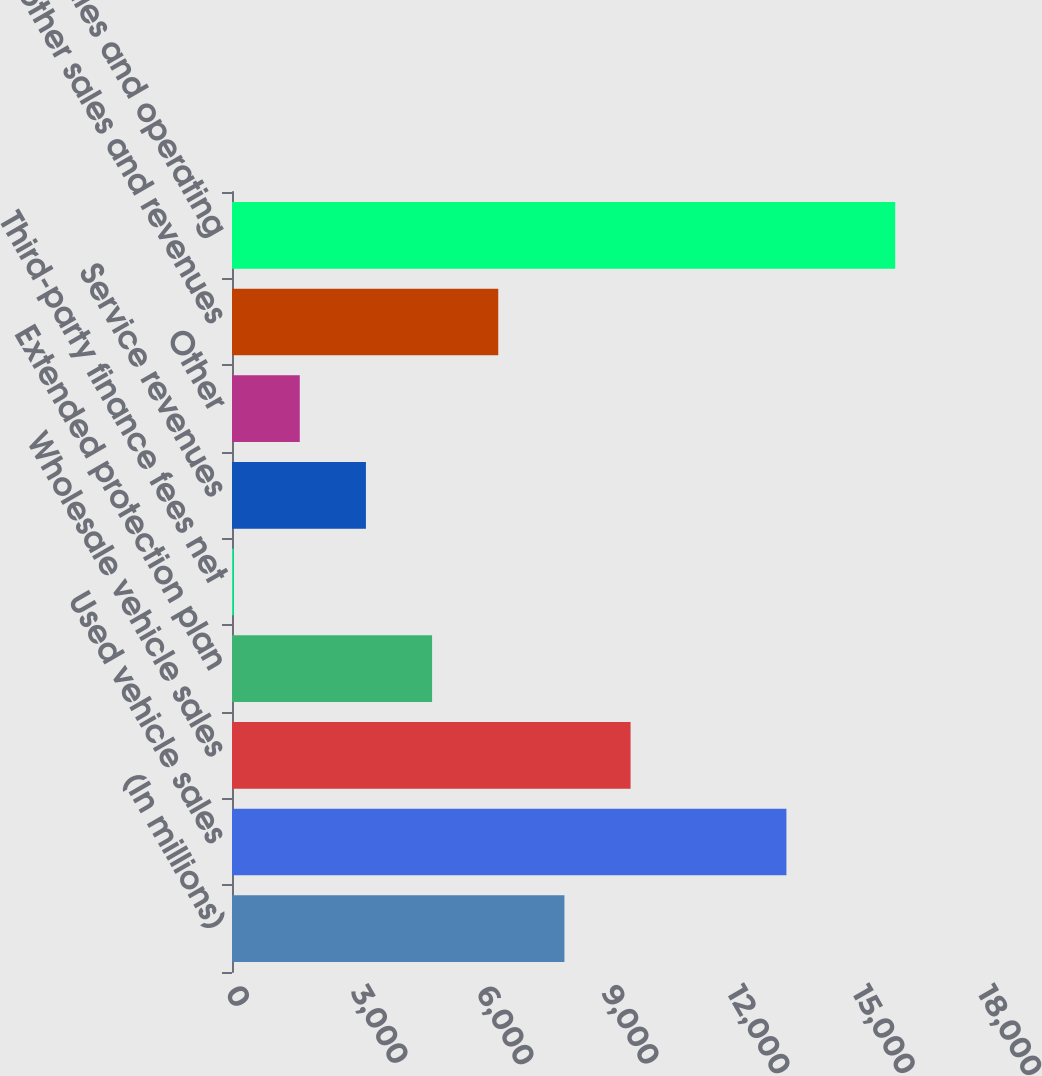<chart> <loc_0><loc_0><loc_500><loc_500><bar_chart><fcel>(In millions)<fcel>Used vehicle sales<fcel>Wholesale vehicle sales<fcel>Extended protection plan<fcel>Third-party finance fees net<fcel>Service revenues<fcel>Other<fcel>Total other sales and revenues<fcel>Total net sales and operating<nl><fcel>7956.75<fcel>13270.7<fcel>9540.42<fcel>4789.41<fcel>38.4<fcel>3205.74<fcel>1622.07<fcel>6373.08<fcel>15875.1<nl></chart> 